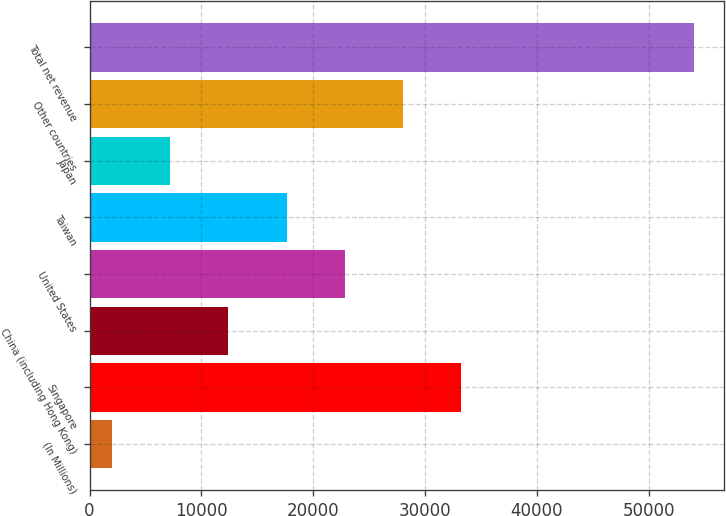Convert chart to OTSL. <chart><loc_0><loc_0><loc_500><loc_500><bar_chart><fcel>(In Millions)<fcel>Singapore<fcel>China (including Hong Kong)<fcel>United States<fcel>Taiwan<fcel>Japan<fcel>Other countries<fcel>Total net revenue<nl><fcel>2011<fcel>33203.8<fcel>12408.6<fcel>22806.2<fcel>17607.4<fcel>7209.8<fcel>28005<fcel>53999<nl></chart> 